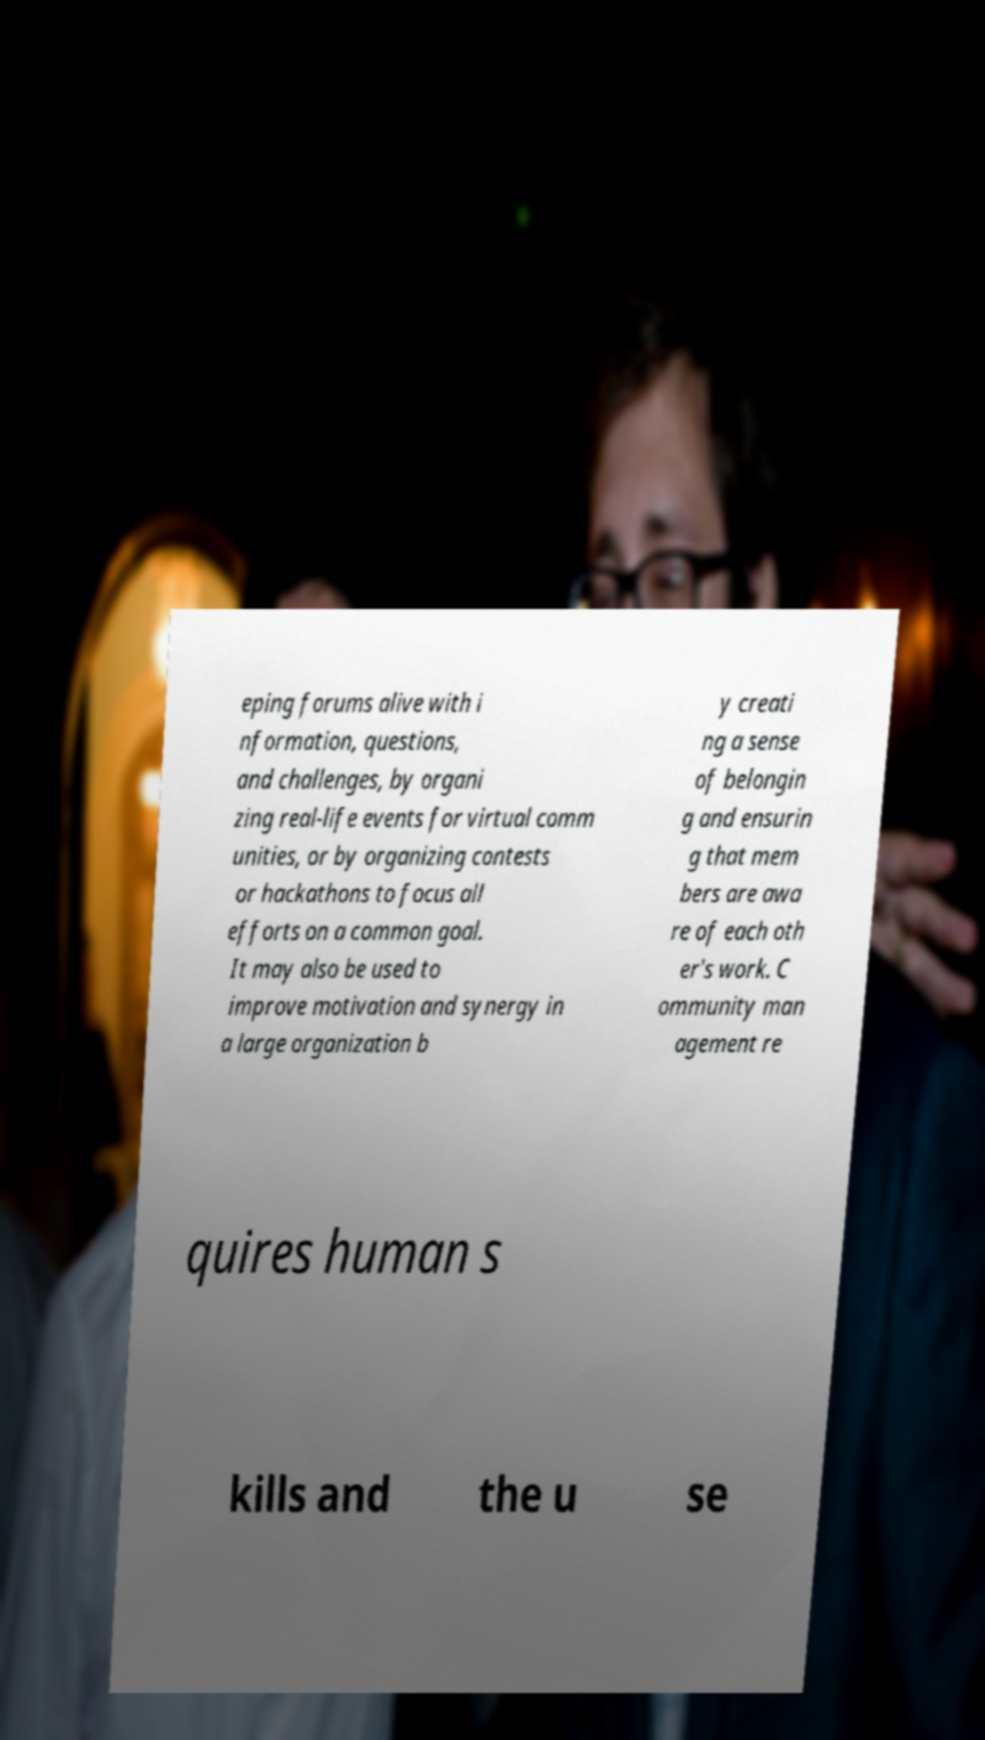Could you extract and type out the text from this image? eping forums alive with i nformation, questions, and challenges, by organi zing real-life events for virtual comm unities, or by organizing contests or hackathons to focus all efforts on a common goal. It may also be used to improve motivation and synergy in a large organization b y creati ng a sense of belongin g and ensurin g that mem bers are awa re of each oth er's work. C ommunity man agement re quires human s kills and the u se 